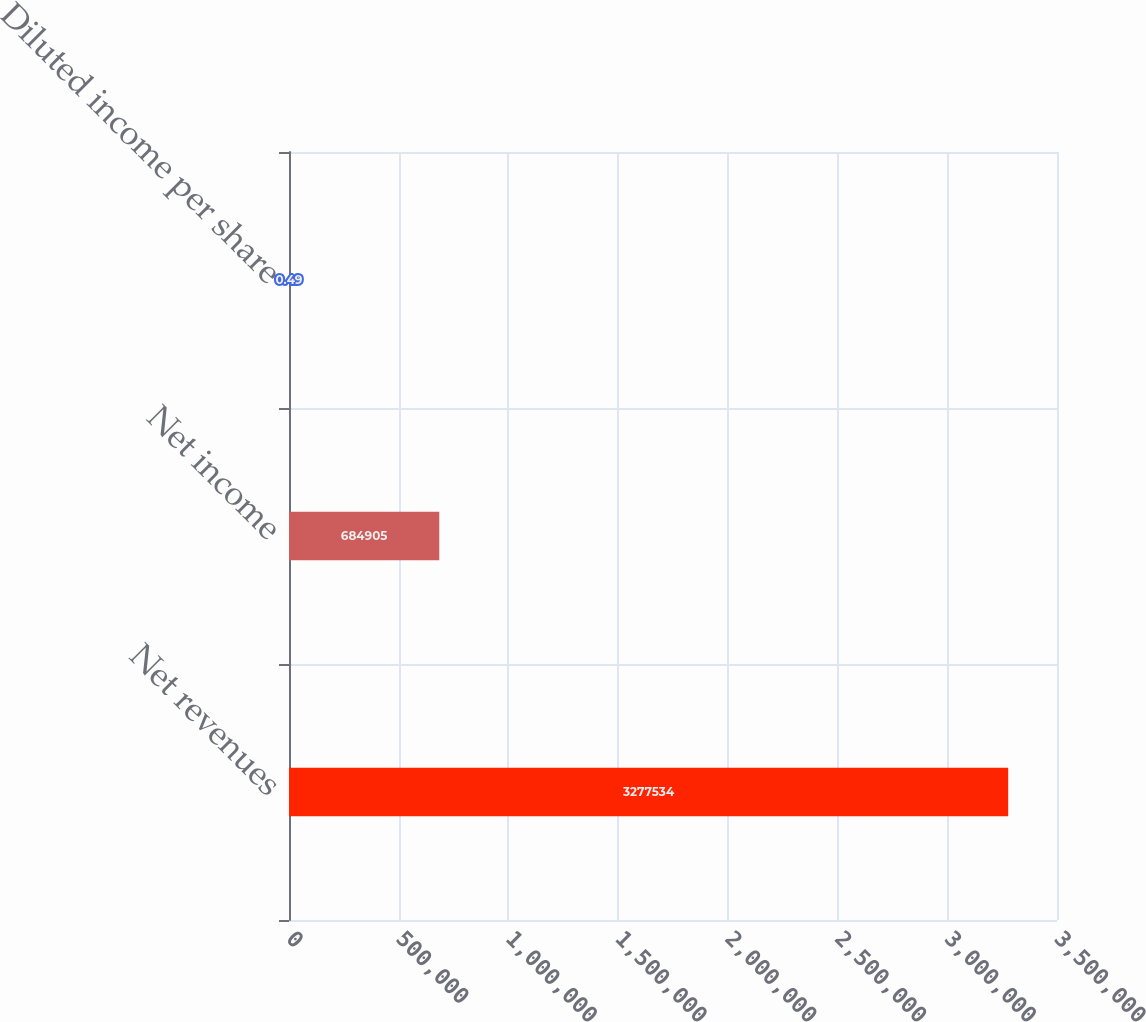<chart> <loc_0><loc_0><loc_500><loc_500><bar_chart><fcel>Net revenues<fcel>Net income<fcel>Diluted income per share<nl><fcel>3.27753e+06<fcel>684905<fcel>0.49<nl></chart> 